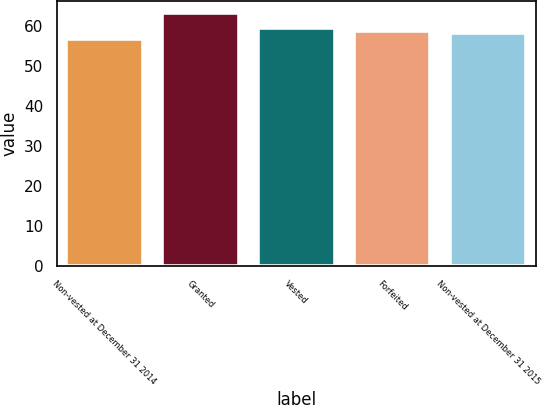<chart> <loc_0><loc_0><loc_500><loc_500><bar_chart><fcel>Non-vested at December 31 2014<fcel>Granted<fcel>Vested<fcel>Forfeited<fcel>Non-vested at December 31 2015<nl><fcel>56.7<fcel>63.12<fcel>59.4<fcel>58.76<fcel>58.12<nl></chart> 